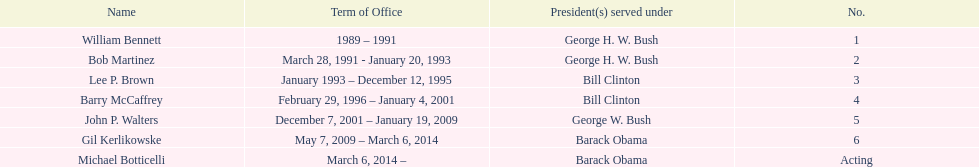What were the total number of years bob martinez served in office? 2. 